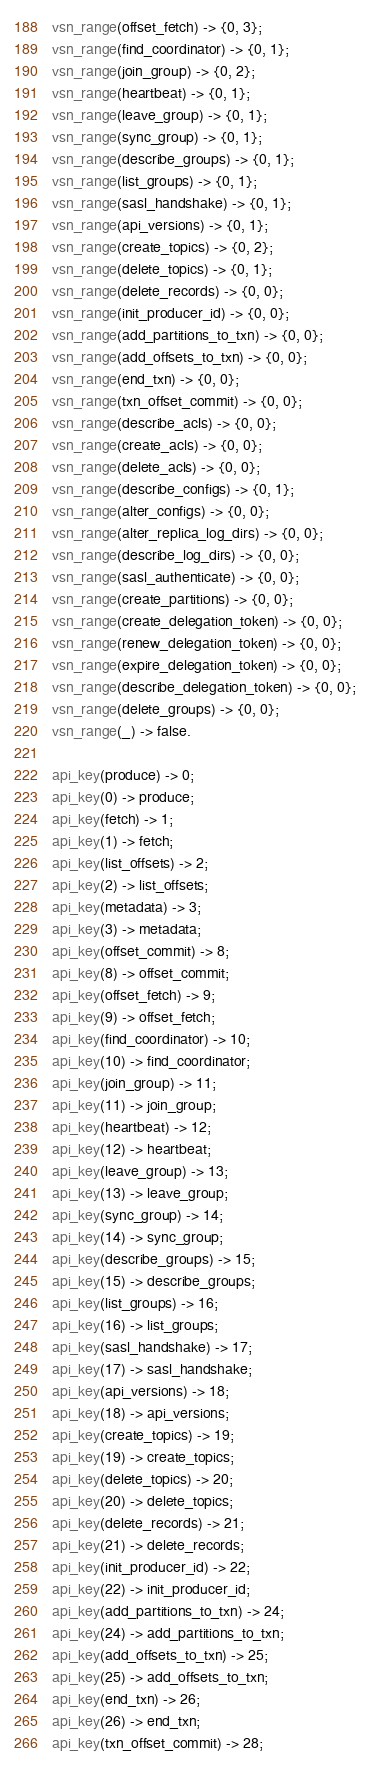<code> <loc_0><loc_0><loc_500><loc_500><_Erlang_>vsn_range(offset_fetch) -> {0, 3};
vsn_range(find_coordinator) -> {0, 1};
vsn_range(join_group) -> {0, 2};
vsn_range(heartbeat) -> {0, 1};
vsn_range(leave_group) -> {0, 1};
vsn_range(sync_group) -> {0, 1};
vsn_range(describe_groups) -> {0, 1};
vsn_range(list_groups) -> {0, 1};
vsn_range(sasl_handshake) -> {0, 1};
vsn_range(api_versions) -> {0, 1};
vsn_range(create_topics) -> {0, 2};
vsn_range(delete_topics) -> {0, 1};
vsn_range(delete_records) -> {0, 0};
vsn_range(init_producer_id) -> {0, 0};
vsn_range(add_partitions_to_txn) -> {0, 0};
vsn_range(add_offsets_to_txn) -> {0, 0};
vsn_range(end_txn) -> {0, 0};
vsn_range(txn_offset_commit) -> {0, 0};
vsn_range(describe_acls) -> {0, 0};
vsn_range(create_acls) -> {0, 0};
vsn_range(delete_acls) -> {0, 0};
vsn_range(describe_configs) -> {0, 1};
vsn_range(alter_configs) -> {0, 0};
vsn_range(alter_replica_log_dirs) -> {0, 0};
vsn_range(describe_log_dirs) -> {0, 0};
vsn_range(sasl_authenticate) -> {0, 0};
vsn_range(create_partitions) -> {0, 0};
vsn_range(create_delegation_token) -> {0, 0};
vsn_range(renew_delegation_token) -> {0, 0};
vsn_range(expire_delegation_token) -> {0, 0};
vsn_range(describe_delegation_token) -> {0, 0};
vsn_range(delete_groups) -> {0, 0};
vsn_range(_) -> false.

api_key(produce) -> 0;
api_key(0) -> produce;
api_key(fetch) -> 1;
api_key(1) -> fetch;
api_key(list_offsets) -> 2;
api_key(2) -> list_offsets;
api_key(metadata) -> 3;
api_key(3) -> metadata;
api_key(offset_commit) -> 8;
api_key(8) -> offset_commit;
api_key(offset_fetch) -> 9;
api_key(9) -> offset_fetch;
api_key(find_coordinator) -> 10;
api_key(10) -> find_coordinator;
api_key(join_group) -> 11;
api_key(11) -> join_group;
api_key(heartbeat) -> 12;
api_key(12) -> heartbeat;
api_key(leave_group) -> 13;
api_key(13) -> leave_group;
api_key(sync_group) -> 14;
api_key(14) -> sync_group;
api_key(describe_groups) -> 15;
api_key(15) -> describe_groups;
api_key(list_groups) -> 16;
api_key(16) -> list_groups;
api_key(sasl_handshake) -> 17;
api_key(17) -> sasl_handshake;
api_key(api_versions) -> 18;
api_key(18) -> api_versions;
api_key(create_topics) -> 19;
api_key(19) -> create_topics;
api_key(delete_topics) -> 20;
api_key(20) -> delete_topics;
api_key(delete_records) -> 21;
api_key(21) -> delete_records;
api_key(init_producer_id) -> 22;
api_key(22) -> init_producer_id;
api_key(add_partitions_to_txn) -> 24;
api_key(24) -> add_partitions_to_txn;
api_key(add_offsets_to_txn) -> 25;
api_key(25) -> add_offsets_to_txn;
api_key(end_txn) -> 26;
api_key(26) -> end_txn;
api_key(txn_offset_commit) -> 28;</code> 